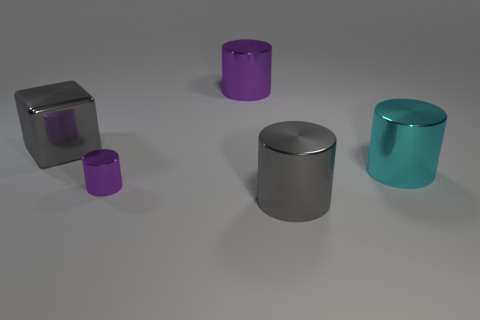How many purple cylinders must be subtracted to get 1 purple cylinders? 1 Subtract all big metal cylinders. How many cylinders are left? 1 Subtract all purple cylinders. How many cylinders are left? 2 Subtract all purple spheres. How many purple cylinders are left? 2 Add 2 purple metallic things. How many objects exist? 7 Subtract 2 cylinders. How many cylinders are left? 2 Subtract all cylinders. How many objects are left? 1 Add 4 large gray cylinders. How many large gray cylinders are left? 5 Add 3 small green objects. How many small green objects exist? 3 Subtract 0 blue spheres. How many objects are left? 5 